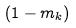Convert formula to latex. <formula><loc_0><loc_0><loc_500><loc_500>( 1 - m _ { k } )</formula> 